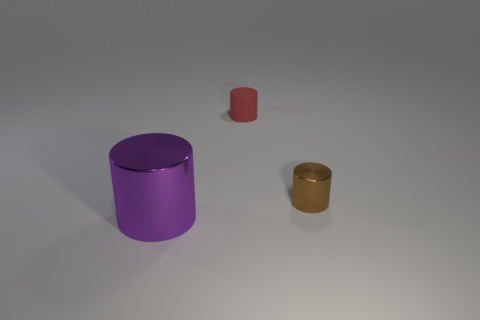Subtract all tiny cylinders. How many cylinders are left? 1 Add 2 tiny red objects. How many objects exist? 5 Subtract all green cylinders. Subtract all green spheres. How many cylinders are left? 3 Add 3 large yellow matte cubes. How many large yellow matte cubes exist? 3 Subtract 0 brown cubes. How many objects are left? 3 Subtract all large green cubes. Subtract all small objects. How many objects are left? 1 Add 3 cylinders. How many cylinders are left? 6 